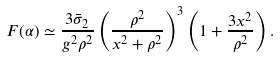Convert formula to latex. <formula><loc_0><loc_0><loc_500><loc_500>F ( \alpha ) \simeq \frac { 3 \bar { \sigma } _ { 2 } } { g ^ { 2 } \rho ^ { 2 } } \left ( \frac { \rho ^ { 2 } } { x ^ { 2 } + \rho ^ { 2 } } \right ) ^ { 3 } \left ( 1 + \frac { 3 x ^ { 2 } } { \rho ^ { 2 } } \right ) .</formula> 